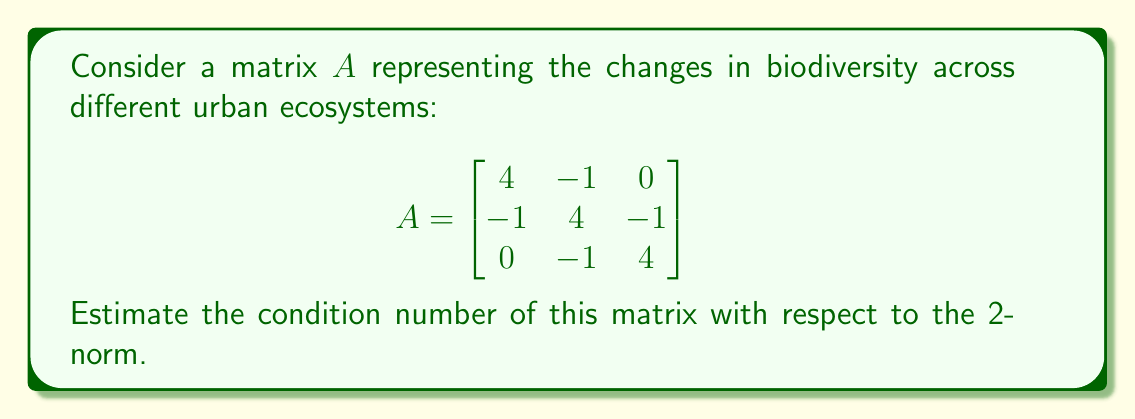What is the answer to this math problem? To estimate the condition number of matrix $A$ with respect to the 2-norm, we need to follow these steps:

1. The condition number is defined as $\kappa(A) = \|A\| \cdot \|A^{-1}\|$, where $\|\cdot\|$ denotes the 2-norm.

2. For the 2-norm, $\|A\| = \sqrt{\lambda_{\max}(A^TA)}$ and $\|A^{-1}\| = \frac{1}{\sqrt{\lambda_{\min}(A^TA)}}$, where $\lambda_{\max}$ and $\lambda_{\min}$ are the largest and smallest eigenvalues of $A^TA$, respectively.

3. Calculate $A^TA$:
   $$A^TA = \begin{bmatrix}
   4 & -1 & 0 \\
   -1 & 4 & -1 \\
   0 & -1 & 4
   \end{bmatrix} \begin{bmatrix}
   4 & -1 & 0 \\
   -1 & 4 & -1 \\
   0 & -1 & 4
   \end{bmatrix} = \begin{bmatrix}
   17 & -8 & 1 \\
   -8 & 18 & -8 \\
   1 & -8 & 17
   \end{bmatrix}$$

4. The characteristic equation of $A^TA$ is:
   $\det(A^TA - \lambda I) = (17-\lambda)(18-\lambda)(17-\lambda) - 64(17-\lambda) - 64(18-\lambda) - (17-\lambda) = 0$

5. Solving this equation gives us the eigenvalues: $\lambda_1 \approx 25.7, \lambda_2 = 18, \lambda_3 \approx 8.3$

6. Therefore, $\lambda_{\max}(A^TA) \approx 25.7$ and $\lambda_{\min}(A^TA) \approx 8.3$

7. Calculate the condition number:
   $$\kappa(A) = \sqrt{\frac{\lambda_{\max}(A^TA)}{\lambda_{\min}(A^TA)}} \approx \sqrt{\frac{25.7}{8.3}} \approx 1.76$$

Thus, the estimated condition number of matrix $A$ with respect to the 2-norm is approximately 1.76.
Answer: $\kappa(A) \approx 1.76$ 